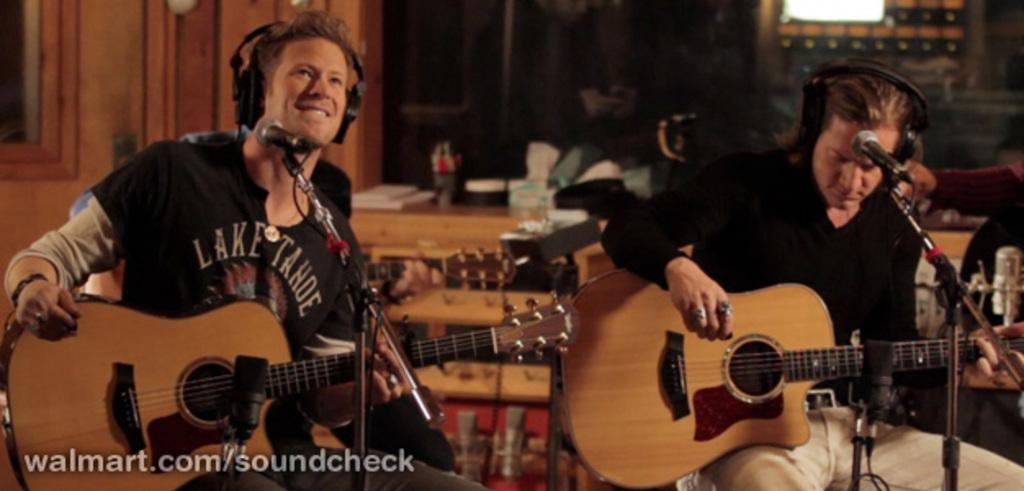How many people are in the image? There are two persons in the image. What are the persons holding in the image? Each person is holding a guitar. What objects are present that might be used for amplifying sound? There are microphones present. What can be seen in the background of the image? There is a table in the background. What type of brush is being used by the person on the left to paint a picture in the image? There is no brush or painting activity present in the image; both persons are holding guitars. 